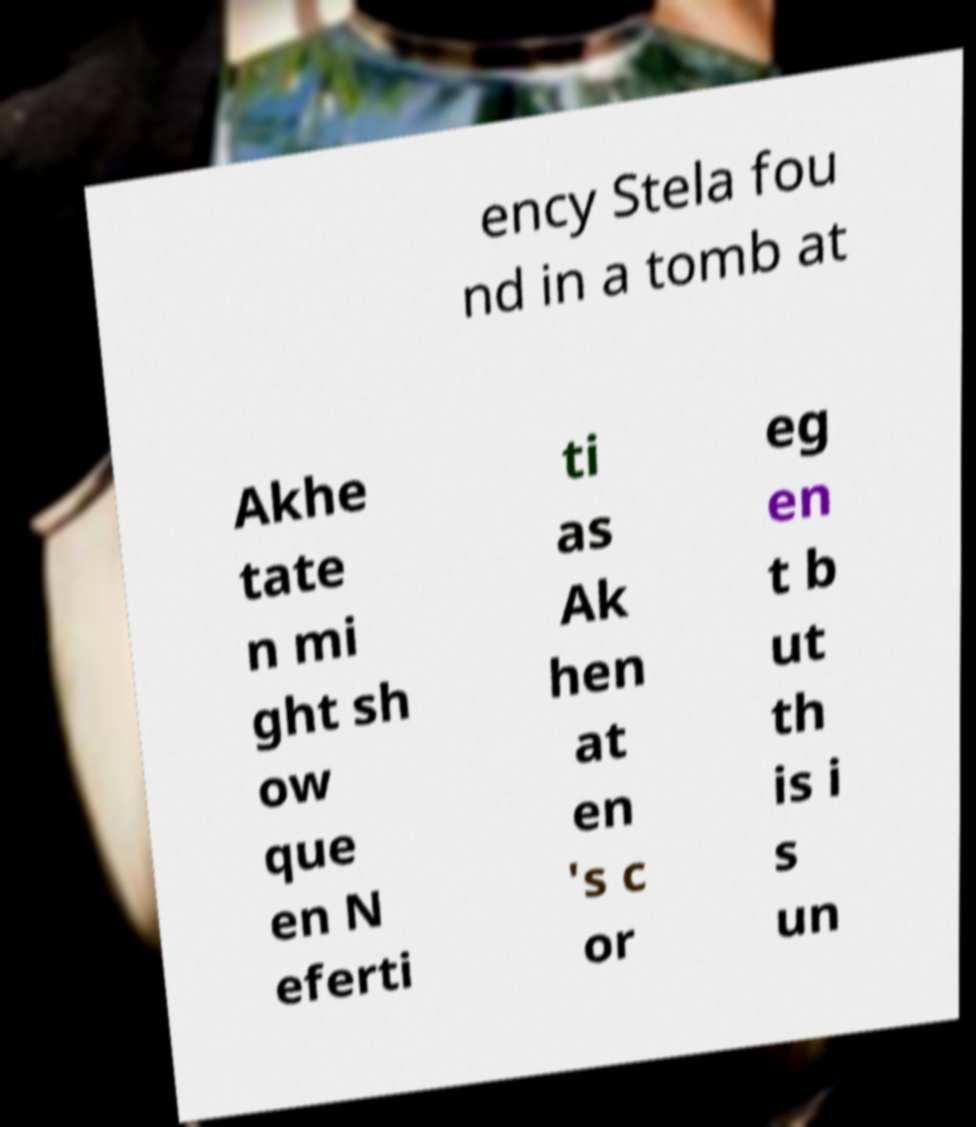Could you assist in decoding the text presented in this image and type it out clearly? ency Stela fou nd in a tomb at Akhe tate n mi ght sh ow que en N eferti ti as Ak hen at en 's c or eg en t b ut th is i s un 